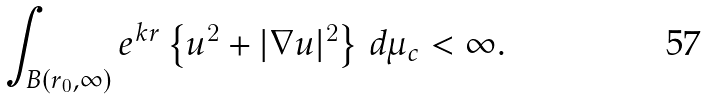Convert formula to latex. <formula><loc_0><loc_0><loc_500><loc_500>\int _ { B ( r _ { 0 } , \infty ) } e ^ { k r } \left \{ u ^ { 2 } + | \nabla u | ^ { 2 } \right \} \, d \mu _ { c } < \infty .</formula> 